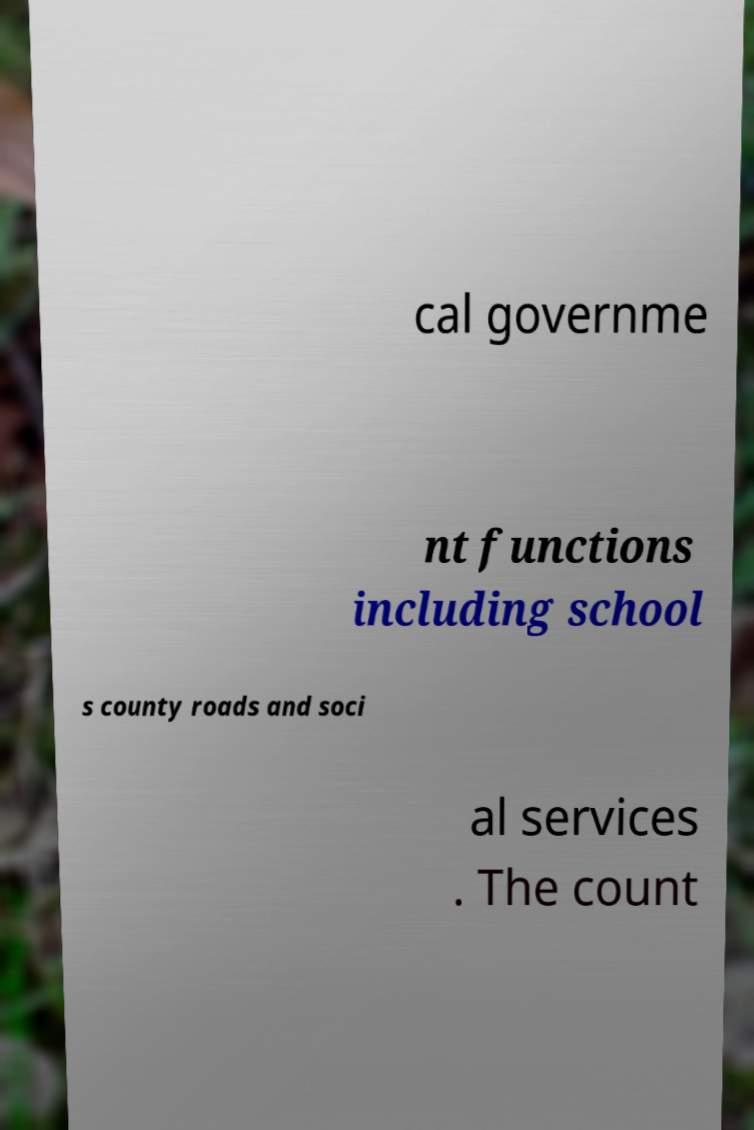There's text embedded in this image that I need extracted. Can you transcribe it verbatim? cal governme nt functions including school s county roads and soci al services . The count 